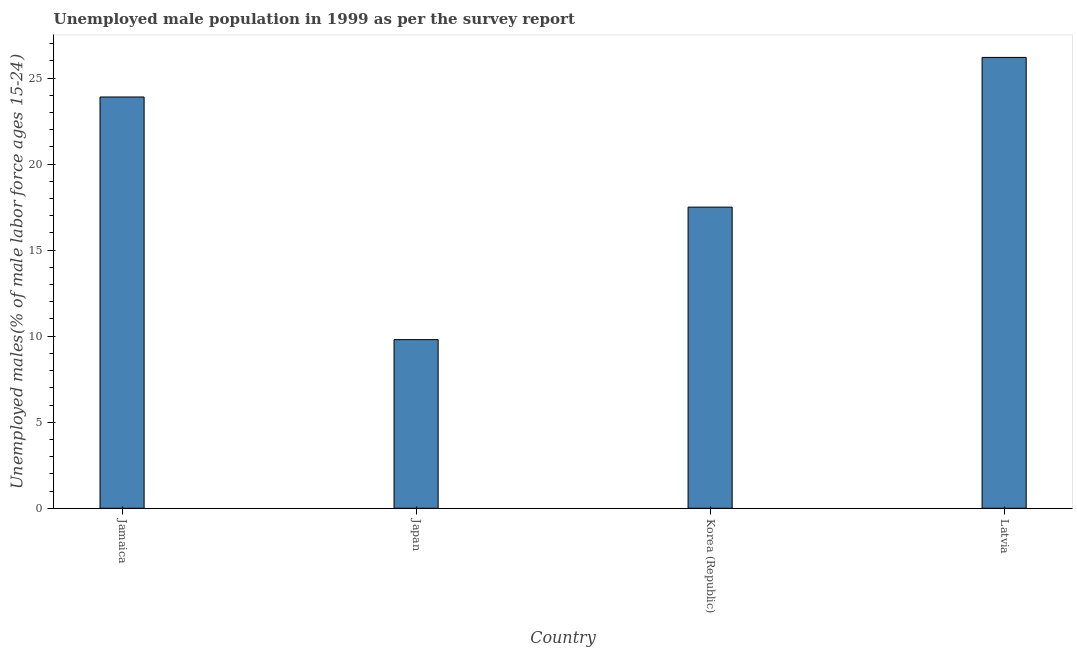What is the title of the graph?
Your response must be concise. Unemployed male population in 1999 as per the survey report. What is the label or title of the Y-axis?
Make the answer very short. Unemployed males(% of male labor force ages 15-24). What is the unemployed male youth in Latvia?
Offer a terse response. 26.2. Across all countries, what is the maximum unemployed male youth?
Give a very brief answer. 26.2. Across all countries, what is the minimum unemployed male youth?
Provide a succinct answer. 9.8. In which country was the unemployed male youth maximum?
Provide a succinct answer. Latvia. What is the sum of the unemployed male youth?
Provide a short and direct response. 77.4. What is the difference between the unemployed male youth in Jamaica and Japan?
Your answer should be compact. 14.1. What is the average unemployed male youth per country?
Offer a terse response. 19.35. What is the median unemployed male youth?
Ensure brevity in your answer.  20.7. What is the ratio of the unemployed male youth in Jamaica to that in Japan?
Provide a succinct answer. 2.44. Is the unemployed male youth in Jamaica less than that in Korea (Republic)?
Make the answer very short. No. Is the difference between the unemployed male youth in Jamaica and Latvia greater than the difference between any two countries?
Your answer should be compact. No. What is the difference between the highest and the second highest unemployed male youth?
Ensure brevity in your answer.  2.3. What is the difference between the highest and the lowest unemployed male youth?
Your answer should be compact. 16.4. How many bars are there?
Ensure brevity in your answer.  4. How many countries are there in the graph?
Provide a short and direct response. 4. What is the difference between two consecutive major ticks on the Y-axis?
Offer a very short reply. 5. What is the Unemployed males(% of male labor force ages 15-24) in Jamaica?
Your response must be concise. 23.9. What is the Unemployed males(% of male labor force ages 15-24) of Japan?
Provide a succinct answer. 9.8. What is the Unemployed males(% of male labor force ages 15-24) of Korea (Republic)?
Keep it short and to the point. 17.5. What is the Unemployed males(% of male labor force ages 15-24) of Latvia?
Offer a terse response. 26.2. What is the difference between the Unemployed males(% of male labor force ages 15-24) in Jamaica and Japan?
Your response must be concise. 14.1. What is the difference between the Unemployed males(% of male labor force ages 15-24) in Jamaica and Korea (Republic)?
Offer a very short reply. 6.4. What is the difference between the Unemployed males(% of male labor force ages 15-24) in Jamaica and Latvia?
Your answer should be compact. -2.3. What is the difference between the Unemployed males(% of male labor force ages 15-24) in Japan and Korea (Republic)?
Your response must be concise. -7.7. What is the difference between the Unemployed males(% of male labor force ages 15-24) in Japan and Latvia?
Make the answer very short. -16.4. What is the difference between the Unemployed males(% of male labor force ages 15-24) in Korea (Republic) and Latvia?
Offer a terse response. -8.7. What is the ratio of the Unemployed males(% of male labor force ages 15-24) in Jamaica to that in Japan?
Make the answer very short. 2.44. What is the ratio of the Unemployed males(% of male labor force ages 15-24) in Jamaica to that in Korea (Republic)?
Give a very brief answer. 1.37. What is the ratio of the Unemployed males(% of male labor force ages 15-24) in Jamaica to that in Latvia?
Your answer should be compact. 0.91. What is the ratio of the Unemployed males(% of male labor force ages 15-24) in Japan to that in Korea (Republic)?
Offer a very short reply. 0.56. What is the ratio of the Unemployed males(% of male labor force ages 15-24) in Japan to that in Latvia?
Make the answer very short. 0.37. What is the ratio of the Unemployed males(% of male labor force ages 15-24) in Korea (Republic) to that in Latvia?
Give a very brief answer. 0.67. 